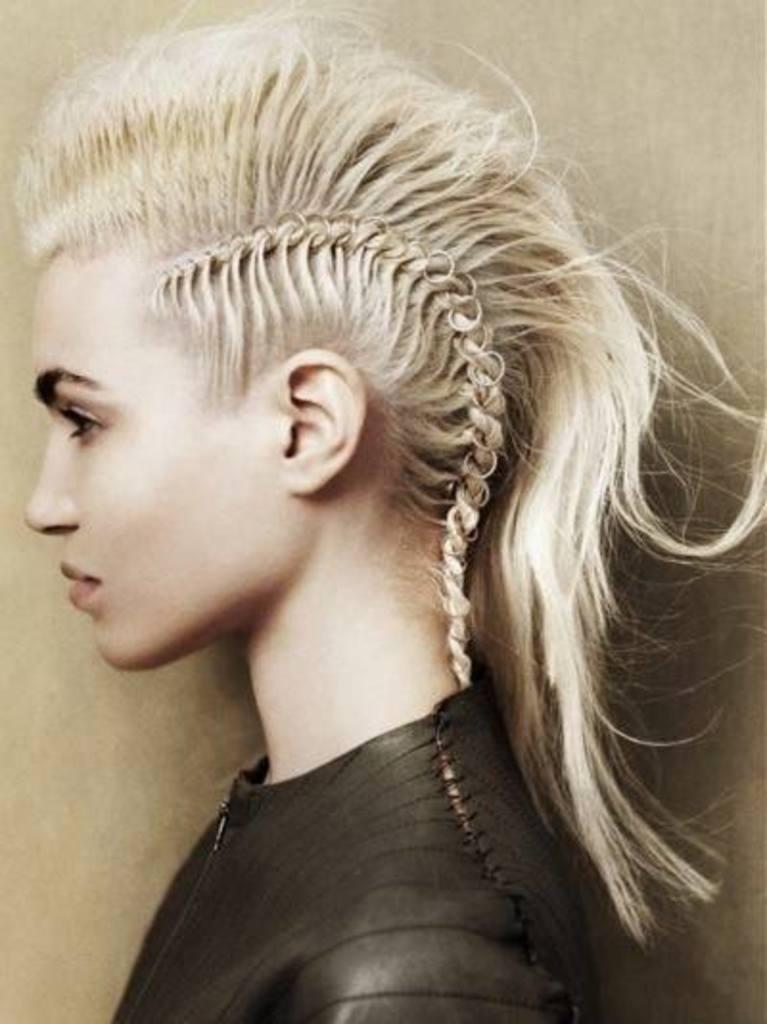Who is the main subject in the image? There is a woman in the image. What is the woman wearing? The woman is wearing a black jacket. What can be seen in the background of the image? There is a well in the background of the image. What type of goat can be seen interacting with the woman in the image? There is no goat present in the image, and therefore no such interaction can be observed. 